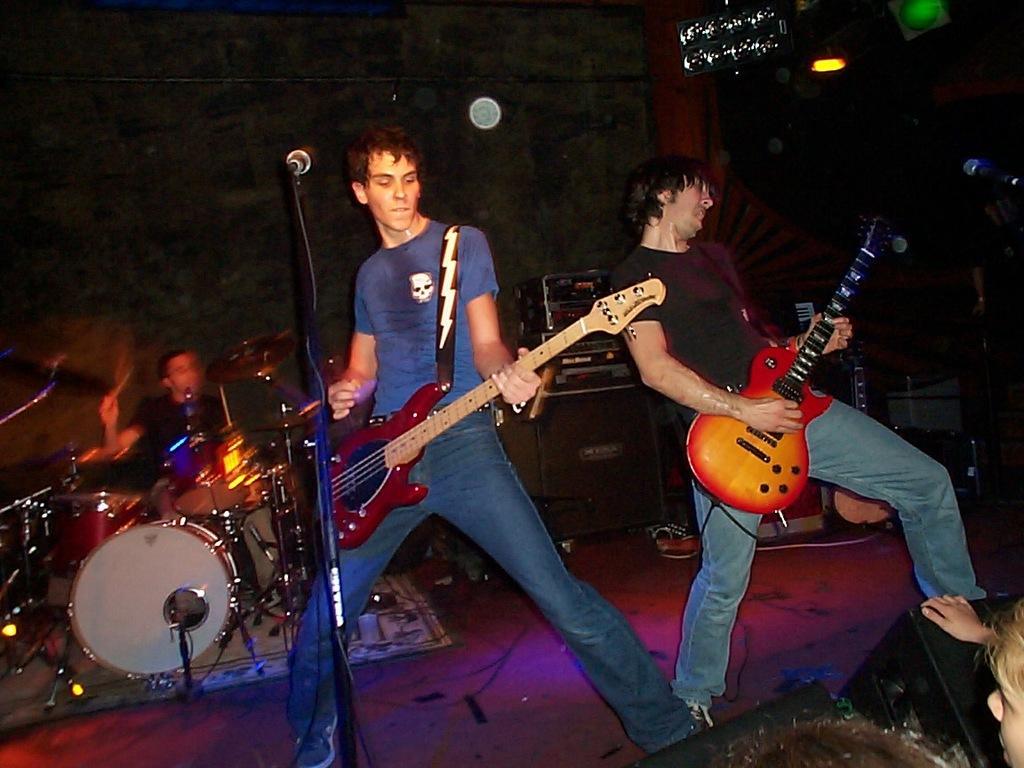How would you summarize this image in a sentence or two? In this picture there are three people, one of them is playing the guitar on to the right side, another person is holding the guitar, there is a microphone and a microphone stand. In the backdrop there is a person sitting and playing the drum set. 